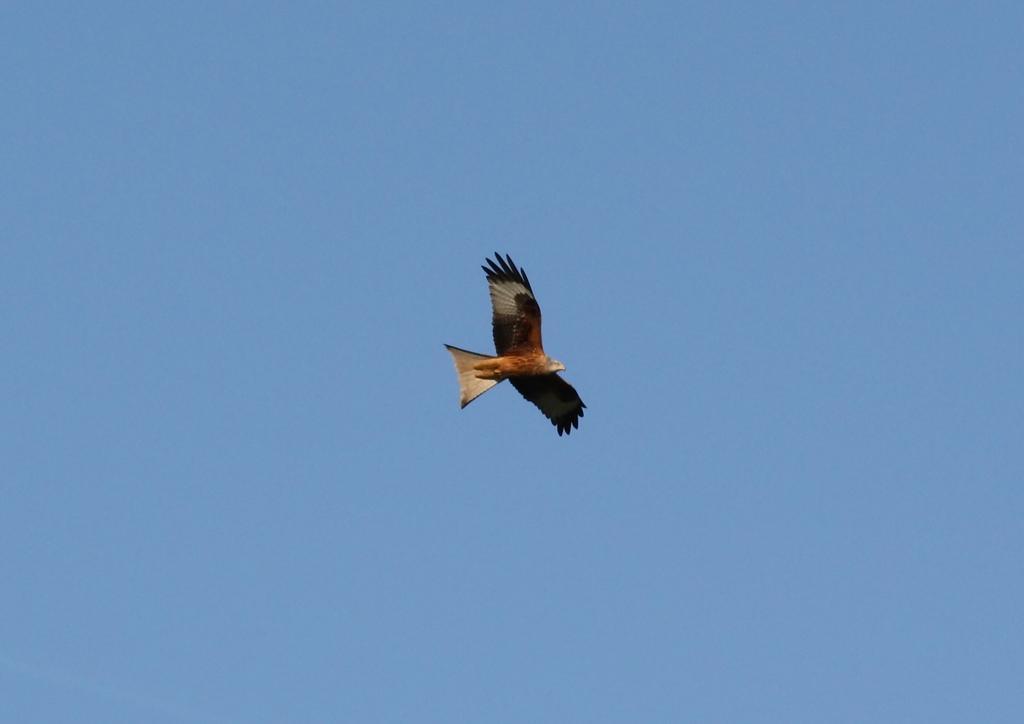How would you summarize this image in a sentence or two? In this image I can see an eagle is flying in the sky. 